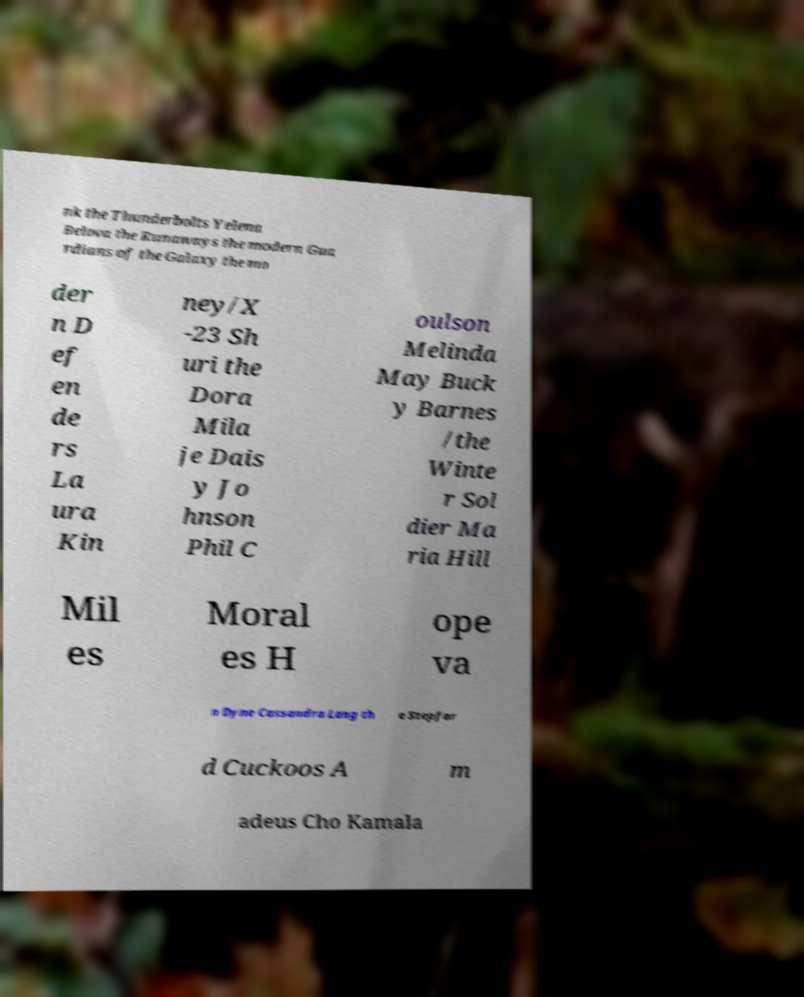Please identify and transcribe the text found in this image. nk the Thunderbolts Yelena Belova the Runaways the modern Gua rdians of the Galaxy the mo der n D ef en de rs La ura Kin ney/X -23 Sh uri the Dora Mila je Dais y Jo hnson Phil C oulson Melinda May Buck y Barnes /the Winte r Sol dier Ma ria Hill Mil es Moral es H ope va n Dyne Cassandra Lang th e Stepfor d Cuckoos A m adeus Cho Kamala 